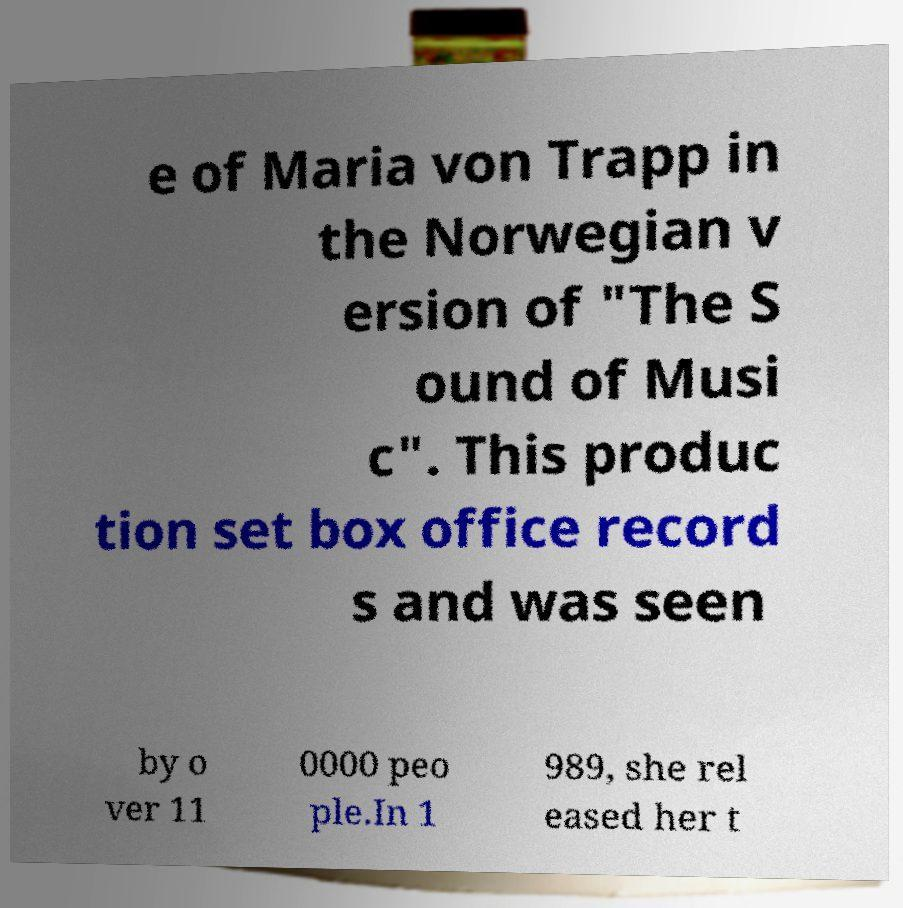Please read and relay the text visible in this image. What does it say? e of Maria von Trapp in the Norwegian v ersion of "The S ound of Musi c". This produc tion set box office record s and was seen by o ver 11 0000 peo ple.In 1 989, she rel eased her t 